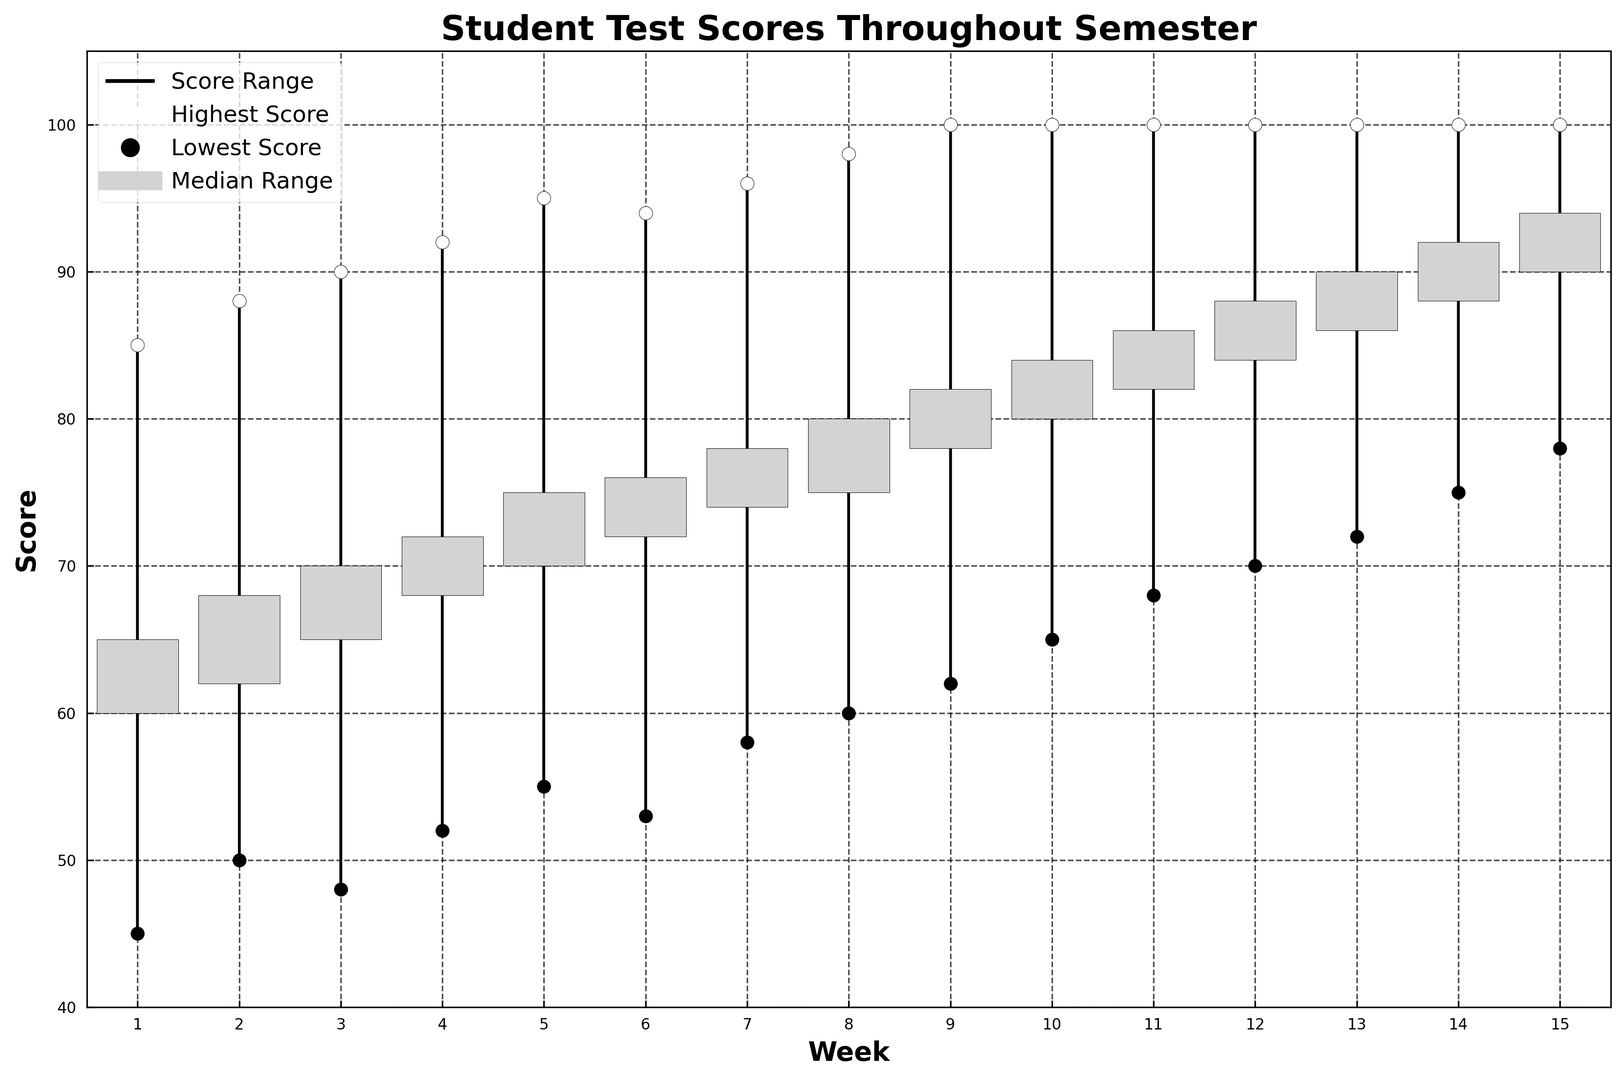What was the highest score in Week 7? Observe the topmost white circle marker in Week 7, which represents the highest score for that week.
Answer: 96 How does the median range from Week 1 compare to Week 8? Check the heights of the candlestick bodies for both Week 1 and Week 8. The body represents the range between the opening and closing medians. Count the difference in heights.
Answer: Week 8 has a higher median range Which week had the lowest median closing score? Look at the bottom of the candlestick bodies to find the lowest closing median.
Answer: Week 1 Is the highest score the same across all weeks? Compare the topmost white circle markers across all weeks. Weeks 9 to 15 have the same highest score of 100, while weeks 1 to 8 vary.
Answer: No What is the difference in the lowest scores between Week 2 and Week 10? Locate the black circle markers representing the lowest scores for Week 2 and Week 10 and note the scores. Calculate the difference: 65 - 50 = 15.
Answer: 15 Which week had the highest increase in closing median from the previous week? Calculate the difference between closing medians of consecutive weeks to find the highest increase. Week 11 and Week 12 have an increase of 2 points from 84 to 86 and from 86 to 88, respectively.
Answer: Week 12 What was the range of scores in Week 5? Identify the lowest and highest scores in Week 5 from the vertical wick. Subtract the lowest score from the highest score.
Answer: 40 (95 - 55) How many weeks had a median range (from opening to closing) greater than 4 points? Look at the candlestick bodies and count the number of weeks where the body's height (difference between closing and opening) is more than 4 points.
Answer: 11 In which week did the lowest score reach above 70? Locate the black circle markers and check the scores. Week 12 and onwards have the lowest score above 70.
Answer: Week 12 Which weeks have both the highest and lowest scores equal to 100? Look at the white and black circle markers at 100 for both highest and lowest scores across weeks. No week has this condition.
Answer: None 